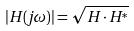Convert formula to latex. <formula><loc_0><loc_0><loc_500><loc_500>| H ( j \omega ) | = \sqrt { H \cdot H ^ { * } }</formula> 